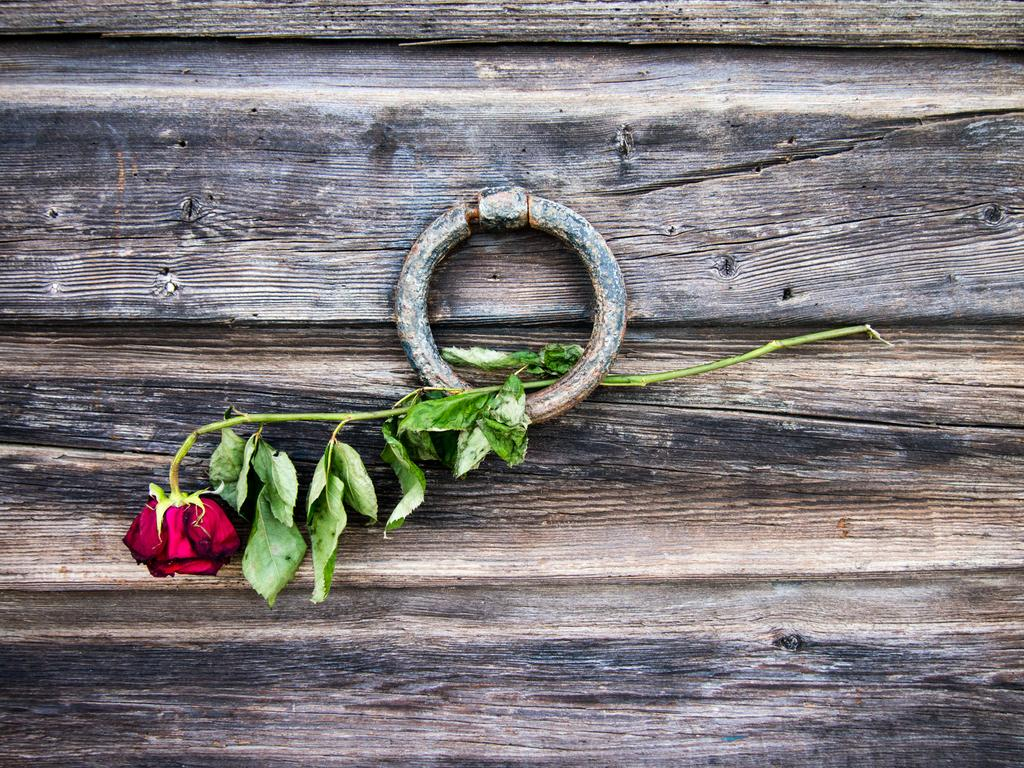What type of flower is in the image? There is a rose flower in the image. How is the rose flower being displayed or held? The rose flower is in an iron ring. What material is the object holding the rose flower made of? The iron ring is on a wooden object. How many nuts are required to build an arch in the image? There is no mention of nuts or an arch in the image; it features a rose flower in an iron ring on a wooden object. 